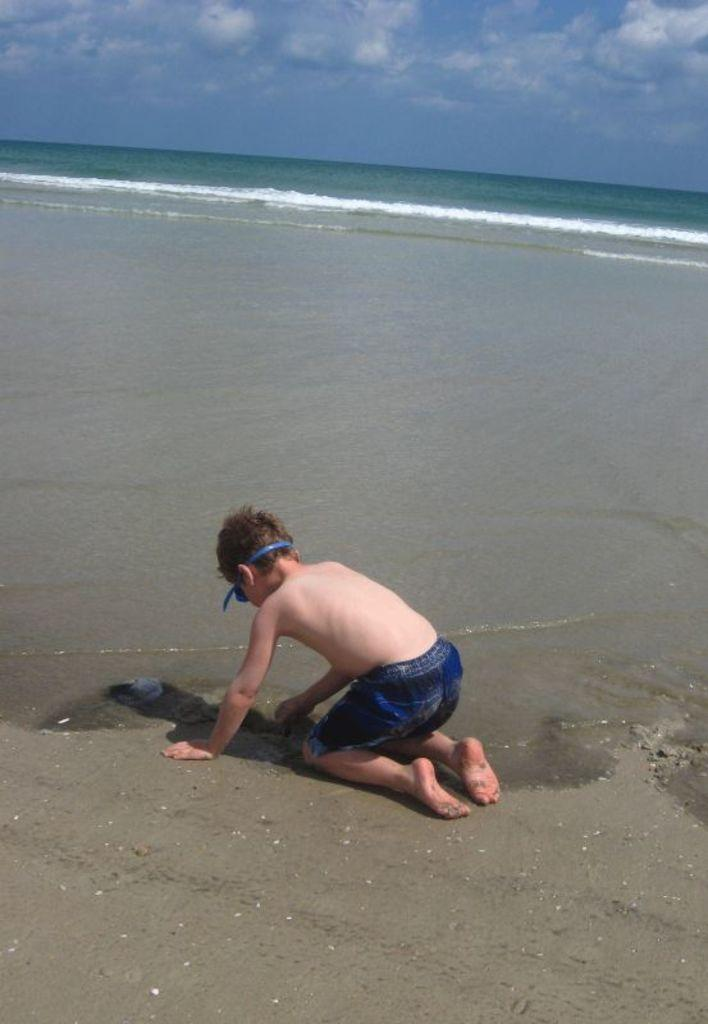Who is visible in the image? There is a boy visible in the image. Where is the boy located in relation to the sea? The boy is in front of the sea. What is visible at the top of the image? The sky is visible at the top of the image. What is the main natural feature visible in the image? The sea is visible in the middle of the image. What type of spoon is the boy using to stir the sea in the image? There is no spoon present in the image, and the boy is not stirring the sea. 